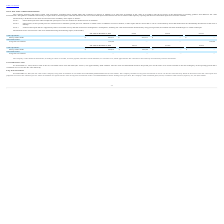According to Ringcentral's financial document, What does Level 1 input in the fair value hierarchy refer to? Observable inputs that reflect unadjusted quoted prices in active markets for identical assets or liabilities. The document states: "Level 1: Observable inputs that reflect unadjusted quoted prices in active markets for identical assets or liabilities...." Also, What does Level 2 input in the fair value hierarchy refer to? Other inputs, such as quoted prices for similar assets or liabilities, quoted prices for identical or similar assets or liabilities in inactive markets, or other inputs that are observable or can be corroborated by observable market data for substantially the full term of the asset or liability. The document states: "Level 2: Other inputs, such as quoted prices for similar assets or liabilities, quoted prices for identical or similar assets or liabilities in inacti..." Also, What does Level 3 input in the fair value hierarchy refer to? Unobservable inputs that are supported by little or no market activity and that are based on management’s assumptions. The document states: "Level 3: Unobservable inputs that are supported by little or no market activity and that are based on management’s assumptions, including fair value m..." Also, can you calculate: What is the total fair value of money market funds and long-term investments at December 31, 2019? Based on the calculation: 297,311 + 132,188 , the result is 429499 (in thousands). This is based on the information: "Long-term investments 132,188 — — 132,188 Money market funds $ 297,311 $ 297,311 $ — $ —..." The key data points involved are: 132,188, 297,311. Also, can you calculate: What is the total value of money market funds in 2018 and 2019? Based on the calculation: 297,311 + 485,872 , the result is 783183 (in thousands). This is based on the information: "Money market funds $ 485,872 $ 485,872 $ — $ — Money market funds $ 297,311 $ 297,311 $ — $ —..." The key data points involved are: 297,311, 485,872. Also, can you calculate: What is the percentage change in the company's money market funds between 2018 and 2019? To answer this question, I need to perform calculations using the financial data. The calculation is: (297,311 - 485,872)/485,872 , which equals -38.81 (percentage). This is based on the information: "Money market funds $ 485,872 $ 485,872 $ — $ — Money market funds $ 297,311 $ 297,311 $ — $ —..." The key data points involved are: 297,311, 485,872. 